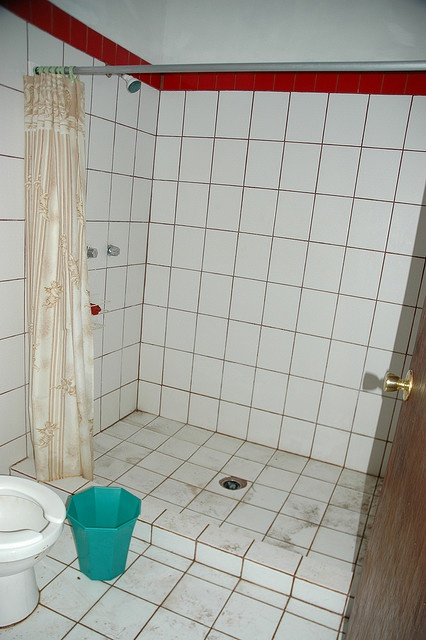Describe the objects in this image and their specific colors. I can see a toilet in black, lightgray, and darkgray tones in this image. 